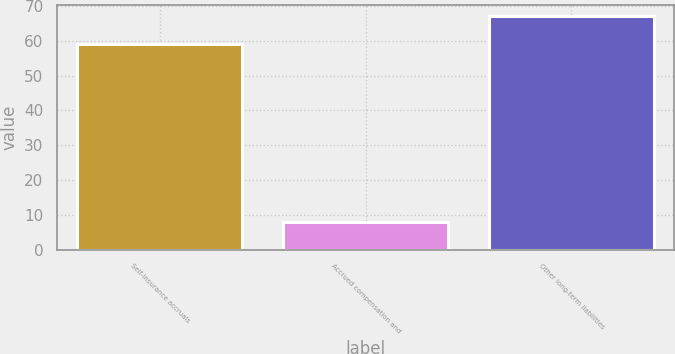<chart> <loc_0><loc_0><loc_500><loc_500><bar_chart><fcel>Self-insurance accruals<fcel>Accrued compensation and<fcel>Other long-term liabilities<nl><fcel>59<fcel>8<fcel>67<nl></chart> 